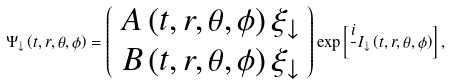Convert formula to latex. <formula><loc_0><loc_0><loc_500><loc_500>\Psi _ { \downarrow } \left ( t , r , \theta , \phi \right ) = \left ( \begin{array} { c } A \left ( t , r , \theta , \phi \right ) \xi _ { \downarrow } \\ B \left ( t , r , \theta , \phi \right ) \xi _ { \downarrow } \end{array} \right ) \exp \left [ \frac { i } { } I _ { \downarrow } \left ( t , r , \theta , \phi \right ) \right ] ,</formula> 